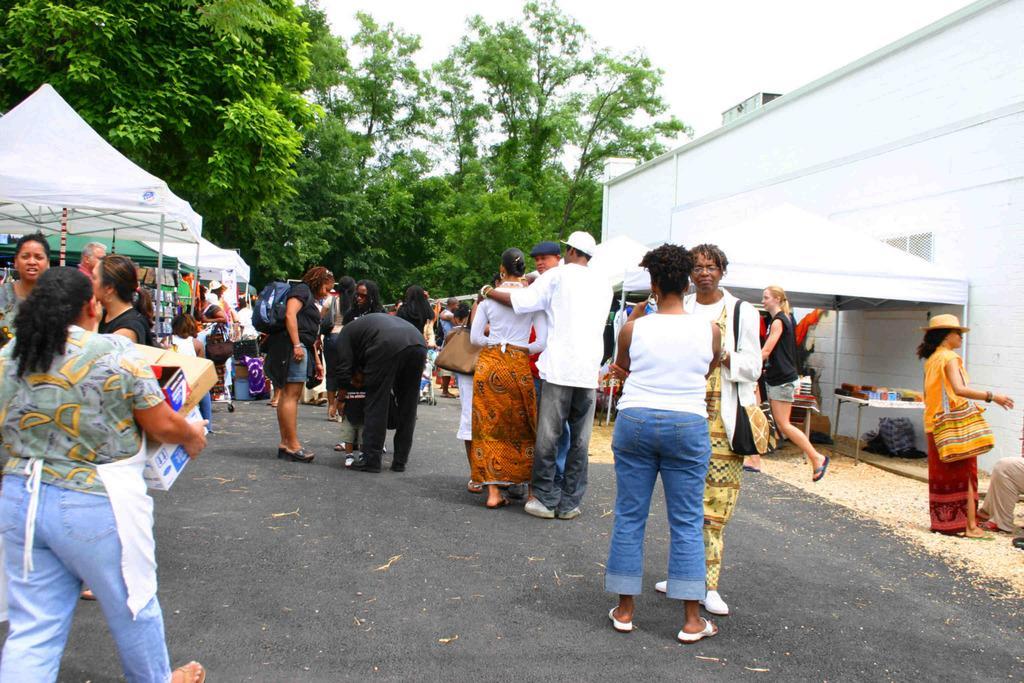Could you give a brief overview of what you see in this image? In this image we can see some people and there are some tents and we can see some objects and there is a building on the right side of the image. We can see some trees and at the top we can see the sky. 